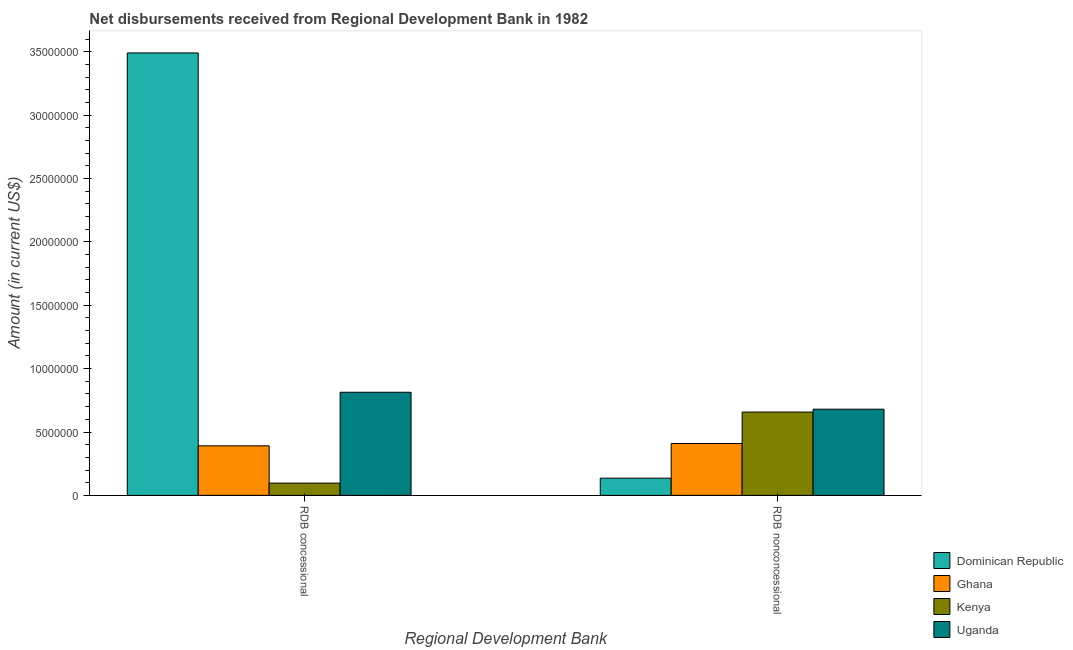How many different coloured bars are there?
Your response must be concise. 4. Are the number of bars per tick equal to the number of legend labels?
Ensure brevity in your answer.  Yes. Are the number of bars on each tick of the X-axis equal?
Provide a short and direct response. Yes. What is the label of the 2nd group of bars from the left?
Provide a short and direct response. RDB nonconcessional. What is the net non concessional disbursements from rdb in Dominican Republic?
Provide a short and direct response. 1.36e+06. Across all countries, what is the maximum net concessional disbursements from rdb?
Offer a very short reply. 3.49e+07. Across all countries, what is the minimum net concessional disbursements from rdb?
Your answer should be compact. 9.68e+05. In which country was the net non concessional disbursements from rdb maximum?
Your answer should be very brief. Uganda. In which country was the net non concessional disbursements from rdb minimum?
Offer a very short reply. Dominican Republic. What is the total net concessional disbursements from rdb in the graph?
Your answer should be compact. 4.79e+07. What is the difference between the net concessional disbursements from rdb in Ghana and that in Kenya?
Your answer should be compact. 2.94e+06. What is the difference between the net non concessional disbursements from rdb in Dominican Republic and the net concessional disbursements from rdb in Uganda?
Offer a terse response. -6.78e+06. What is the average net non concessional disbursements from rdb per country?
Give a very brief answer. 4.71e+06. What is the difference between the net non concessional disbursements from rdb and net concessional disbursements from rdb in Uganda?
Make the answer very short. -1.34e+06. In how many countries, is the net non concessional disbursements from rdb greater than 4000000 US$?
Provide a short and direct response. 3. What is the ratio of the net concessional disbursements from rdb in Uganda to that in Dominican Republic?
Make the answer very short. 0.23. Is the net concessional disbursements from rdb in Uganda less than that in Dominican Republic?
Provide a short and direct response. Yes. What does the 1st bar from the right in RDB concessional represents?
Offer a terse response. Uganda. How many bars are there?
Your answer should be compact. 8. Are all the bars in the graph horizontal?
Offer a terse response. No. Are the values on the major ticks of Y-axis written in scientific E-notation?
Keep it short and to the point. No. Where does the legend appear in the graph?
Offer a terse response. Bottom right. How are the legend labels stacked?
Offer a very short reply. Vertical. What is the title of the graph?
Offer a very short reply. Net disbursements received from Regional Development Bank in 1982. What is the label or title of the X-axis?
Provide a succinct answer. Regional Development Bank. What is the Amount (in current US$) in Dominican Republic in RDB concessional?
Give a very brief answer. 3.49e+07. What is the Amount (in current US$) of Ghana in RDB concessional?
Ensure brevity in your answer.  3.91e+06. What is the Amount (in current US$) of Kenya in RDB concessional?
Offer a terse response. 9.68e+05. What is the Amount (in current US$) in Uganda in RDB concessional?
Give a very brief answer. 8.14e+06. What is the Amount (in current US$) of Dominican Republic in RDB nonconcessional?
Provide a short and direct response. 1.36e+06. What is the Amount (in current US$) in Ghana in RDB nonconcessional?
Your response must be concise. 4.09e+06. What is the Amount (in current US$) in Kenya in RDB nonconcessional?
Give a very brief answer. 6.58e+06. What is the Amount (in current US$) in Uganda in RDB nonconcessional?
Give a very brief answer. 6.80e+06. Across all Regional Development Bank, what is the maximum Amount (in current US$) in Dominican Republic?
Keep it short and to the point. 3.49e+07. Across all Regional Development Bank, what is the maximum Amount (in current US$) in Ghana?
Provide a succinct answer. 4.09e+06. Across all Regional Development Bank, what is the maximum Amount (in current US$) in Kenya?
Offer a very short reply. 6.58e+06. Across all Regional Development Bank, what is the maximum Amount (in current US$) of Uganda?
Give a very brief answer. 8.14e+06. Across all Regional Development Bank, what is the minimum Amount (in current US$) in Dominican Republic?
Keep it short and to the point. 1.36e+06. Across all Regional Development Bank, what is the minimum Amount (in current US$) in Ghana?
Provide a succinct answer. 3.91e+06. Across all Regional Development Bank, what is the minimum Amount (in current US$) in Kenya?
Your answer should be very brief. 9.68e+05. Across all Regional Development Bank, what is the minimum Amount (in current US$) in Uganda?
Offer a very short reply. 6.80e+06. What is the total Amount (in current US$) in Dominican Republic in the graph?
Give a very brief answer. 3.63e+07. What is the total Amount (in current US$) of Ghana in the graph?
Your answer should be very brief. 8.00e+06. What is the total Amount (in current US$) of Kenya in the graph?
Make the answer very short. 7.54e+06. What is the total Amount (in current US$) of Uganda in the graph?
Offer a terse response. 1.49e+07. What is the difference between the Amount (in current US$) of Dominican Republic in RDB concessional and that in RDB nonconcessional?
Your response must be concise. 3.35e+07. What is the difference between the Amount (in current US$) in Ghana in RDB concessional and that in RDB nonconcessional?
Your response must be concise. -1.84e+05. What is the difference between the Amount (in current US$) of Kenya in RDB concessional and that in RDB nonconcessional?
Ensure brevity in your answer.  -5.61e+06. What is the difference between the Amount (in current US$) of Uganda in RDB concessional and that in RDB nonconcessional?
Your answer should be very brief. 1.34e+06. What is the difference between the Amount (in current US$) in Dominican Republic in RDB concessional and the Amount (in current US$) in Ghana in RDB nonconcessional?
Your answer should be very brief. 3.08e+07. What is the difference between the Amount (in current US$) in Dominican Republic in RDB concessional and the Amount (in current US$) in Kenya in RDB nonconcessional?
Your response must be concise. 2.83e+07. What is the difference between the Amount (in current US$) of Dominican Republic in RDB concessional and the Amount (in current US$) of Uganda in RDB nonconcessional?
Provide a short and direct response. 2.81e+07. What is the difference between the Amount (in current US$) of Ghana in RDB concessional and the Amount (in current US$) of Kenya in RDB nonconcessional?
Provide a short and direct response. -2.66e+06. What is the difference between the Amount (in current US$) in Ghana in RDB concessional and the Amount (in current US$) in Uganda in RDB nonconcessional?
Keep it short and to the point. -2.89e+06. What is the difference between the Amount (in current US$) in Kenya in RDB concessional and the Amount (in current US$) in Uganda in RDB nonconcessional?
Make the answer very short. -5.83e+06. What is the average Amount (in current US$) in Dominican Republic per Regional Development Bank?
Your answer should be compact. 1.81e+07. What is the average Amount (in current US$) in Ghana per Regional Development Bank?
Provide a short and direct response. 4.00e+06. What is the average Amount (in current US$) of Kenya per Regional Development Bank?
Keep it short and to the point. 3.77e+06. What is the average Amount (in current US$) in Uganda per Regional Development Bank?
Give a very brief answer. 7.47e+06. What is the difference between the Amount (in current US$) in Dominican Republic and Amount (in current US$) in Ghana in RDB concessional?
Ensure brevity in your answer.  3.10e+07. What is the difference between the Amount (in current US$) of Dominican Republic and Amount (in current US$) of Kenya in RDB concessional?
Give a very brief answer. 3.39e+07. What is the difference between the Amount (in current US$) in Dominican Republic and Amount (in current US$) in Uganda in RDB concessional?
Offer a terse response. 2.68e+07. What is the difference between the Amount (in current US$) of Ghana and Amount (in current US$) of Kenya in RDB concessional?
Offer a very short reply. 2.94e+06. What is the difference between the Amount (in current US$) in Ghana and Amount (in current US$) in Uganda in RDB concessional?
Keep it short and to the point. -4.23e+06. What is the difference between the Amount (in current US$) of Kenya and Amount (in current US$) of Uganda in RDB concessional?
Give a very brief answer. -7.17e+06. What is the difference between the Amount (in current US$) in Dominican Republic and Amount (in current US$) in Ghana in RDB nonconcessional?
Ensure brevity in your answer.  -2.74e+06. What is the difference between the Amount (in current US$) in Dominican Republic and Amount (in current US$) in Kenya in RDB nonconcessional?
Ensure brevity in your answer.  -5.22e+06. What is the difference between the Amount (in current US$) in Dominican Republic and Amount (in current US$) in Uganda in RDB nonconcessional?
Provide a succinct answer. -5.44e+06. What is the difference between the Amount (in current US$) in Ghana and Amount (in current US$) in Kenya in RDB nonconcessional?
Give a very brief answer. -2.48e+06. What is the difference between the Amount (in current US$) in Ghana and Amount (in current US$) in Uganda in RDB nonconcessional?
Make the answer very short. -2.71e+06. What is the difference between the Amount (in current US$) of Kenya and Amount (in current US$) of Uganda in RDB nonconcessional?
Provide a short and direct response. -2.27e+05. What is the ratio of the Amount (in current US$) of Dominican Republic in RDB concessional to that in RDB nonconcessional?
Your answer should be compact. 25.69. What is the ratio of the Amount (in current US$) of Ghana in RDB concessional to that in RDB nonconcessional?
Offer a very short reply. 0.96. What is the ratio of the Amount (in current US$) in Kenya in RDB concessional to that in RDB nonconcessional?
Your answer should be very brief. 0.15. What is the ratio of the Amount (in current US$) in Uganda in RDB concessional to that in RDB nonconcessional?
Make the answer very short. 1.2. What is the difference between the highest and the second highest Amount (in current US$) in Dominican Republic?
Provide a short and direct response. 3.35e+07. What is the difference between the highest and the second highest Amount (in current US$) in Ghana?
Provide a succinct answer. 1.84e+05. What is the difference between the highest and the second highest Amount (in current US$) in Kenya?
Offer a very short reply. 5.61e+06. What is the difference between the highest and the second highest Amount (in current US$) of Uganda?
Make the answer very short. 1.34e+06. What is the difference between the highest and the lowest Amount (in current US$) in Dominican Republic?
Your answer should be compact. 3.35e+07. What is the difference between the highest and the lowest Amount (in current US$) in Ghana?
Provide a short and direct response. 1.84e+05. What is the difference between the highest and the lowest Amount (in current US$) in Kenya?
Your response must be concise. 5.61e+06. What is the difference between the highest and the lowest Amount (in current US$) of Uganda?
Offer a terse response. 1.34e+06. 